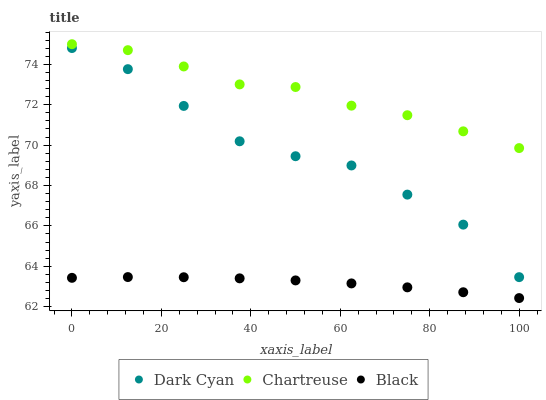Does Black have the minimum area under the curve?
Answer yes or no. Yes. Does Chartreuse have the maximum area under the curve?
Answer yes or no. Yes. Does Chartreuse have the minimum area under the curve?
Answer yes or no. No. Does Black have the maximum area under the curve?
Answer yes or no. No. Is Black the smoothest?
Answer yes or no. Yes. Is Dark Cyan the roughest?
Answer yes or no. Yes. Is Chartreuse the smoothest?
Answer yes or no. No. Is Chartreuse the roughest?
Answer yes or no. No. Does Black have the lowest value?
Answer yes or no. Yes. Does Chartreuse have the lowest value?
Answer yes or no. No. Does Chartreuse have the highest value?
Answer yes or no. Yes. Does Black have the highest value?
Answer yes or no. No. Is Black less than Dark Cyan?
Answer yes or no. Yes. Is Dark Cyan greater than Black?
Answer yes or no. Yes. Does Black intersect Dark Cyan?
Answer yes or no. No. 